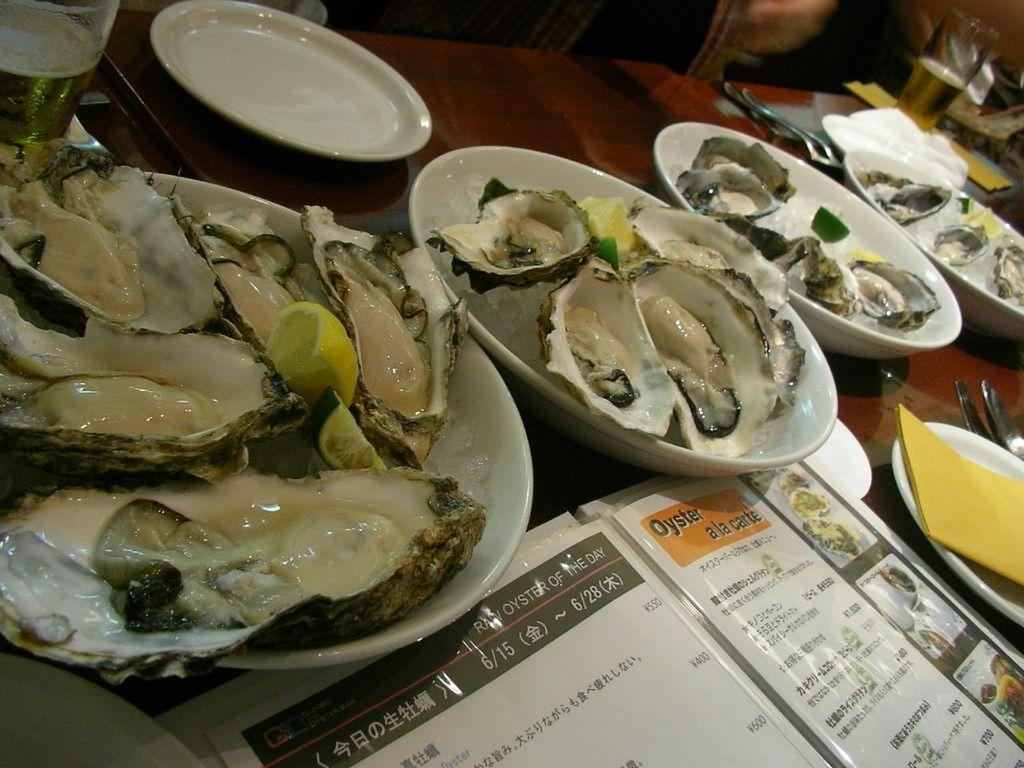What is placed on the white plate in the image? There are eatables placed on a white plate. Where is the white plate located? The plate is on a table. What else can be seen beside the plate on the table? There are other objects beside the plate. How does the plate smash into pieces in the image? The plate does not smash into pieces in the image; it is intact and holding the eatables. 